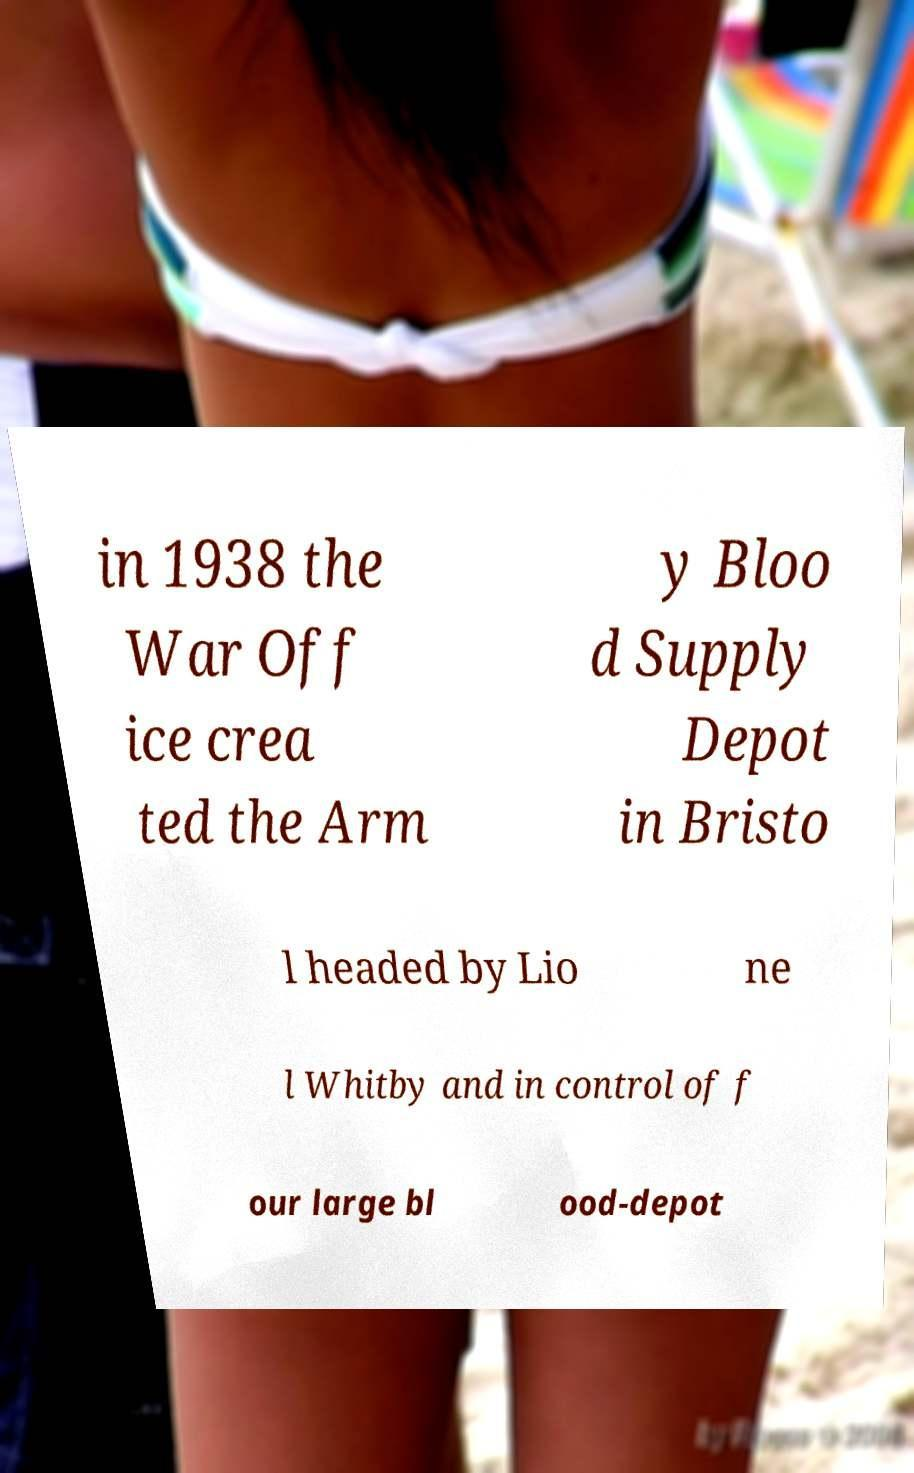Could you extract and type out the text from this image? in 1938 the War Off ice crea ted the Arm y Bloo d Supply Depot in Bristo l headed by Lio ne l Whitby and in control of f our large bl ood-depot 